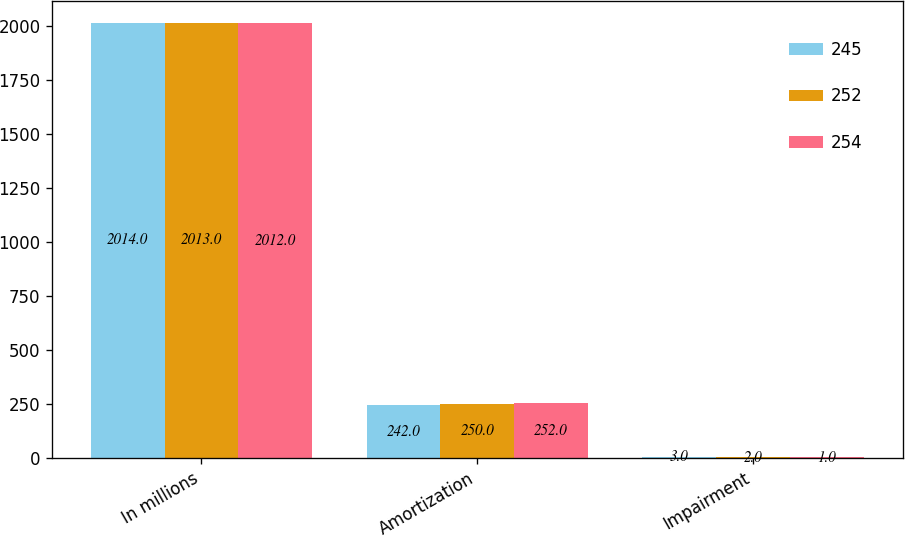Convert chart to OTSL. <chart><loc_0><loc_0><loc_500><loc_500><stacked_bar_chart><ecel><fcel>In millions<fcel>Amortization<fcel>Impairment<nl><fcel>245<fcel>2014<fcel>242<fcel>3<nl><fcel>252<fcel>2013<fcel>250<fcel>2<nl><fcel>254<fcel>2012<fcel>252<fcel>1<nl></chart> 